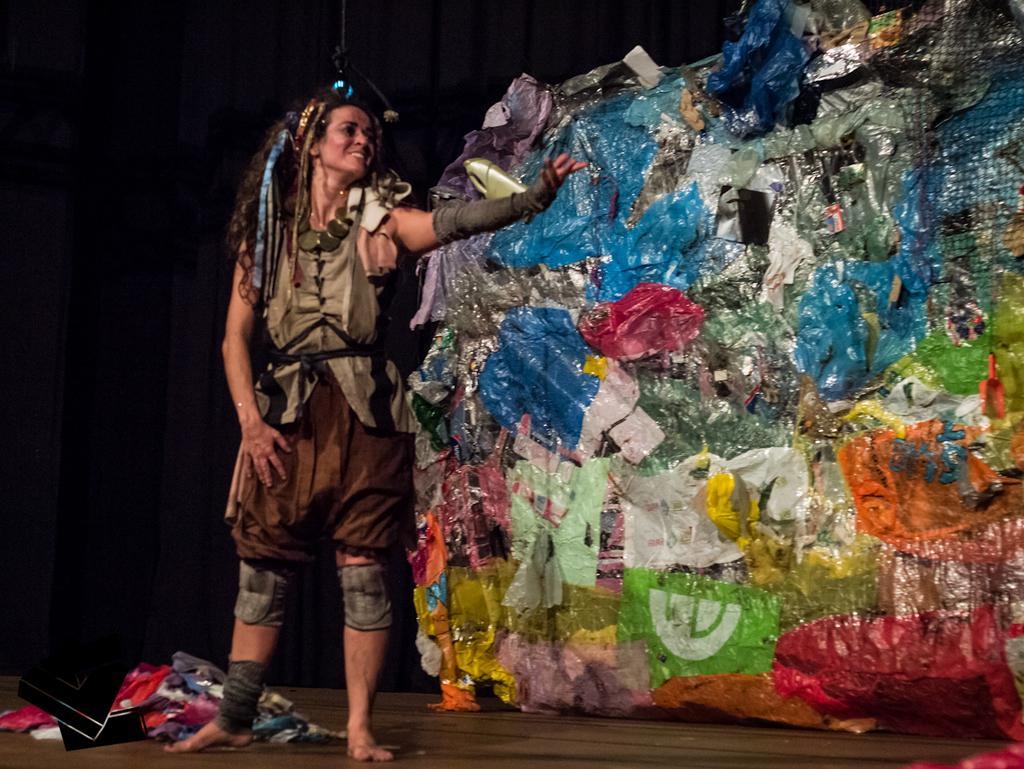How would you summarize this image in a sentence or two? Here is the woman standing and smiling. This looks like an art, which is made of garbage materials. I can see few clothes lying on the floor. 